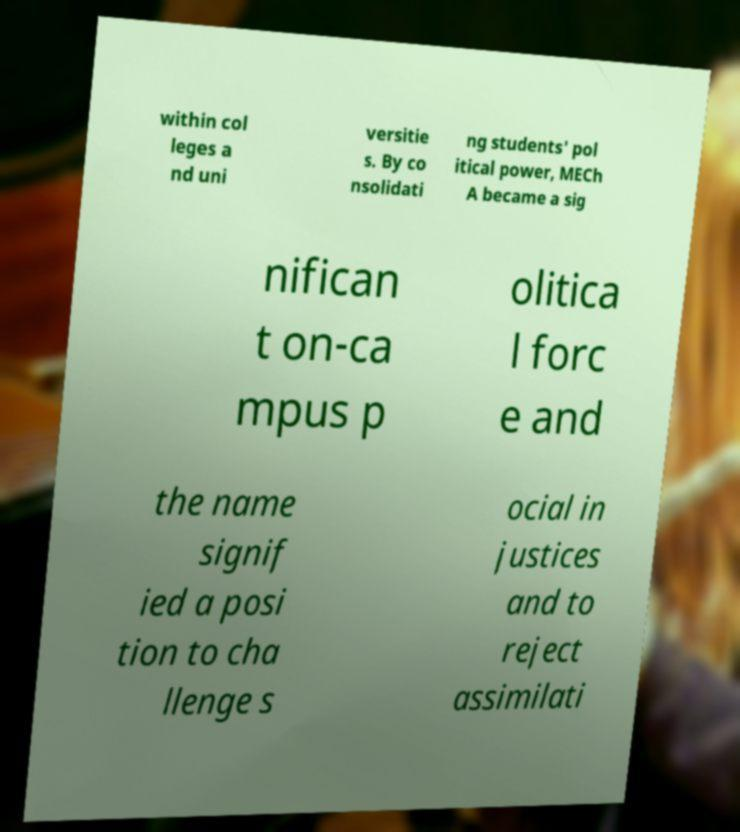Can you read and provide the text displayed in the image?This photo seems to have some interesting text. Can you extract and type it out for me? within col leges a nd uni versitie s. By co nsolidati ng students' pol itical power, MECh A became a sig nifican t on-ca mpus p olitica l forc e and the name signif ied a posi tion to cha llenge s ocial in justices and to reject assimilati 